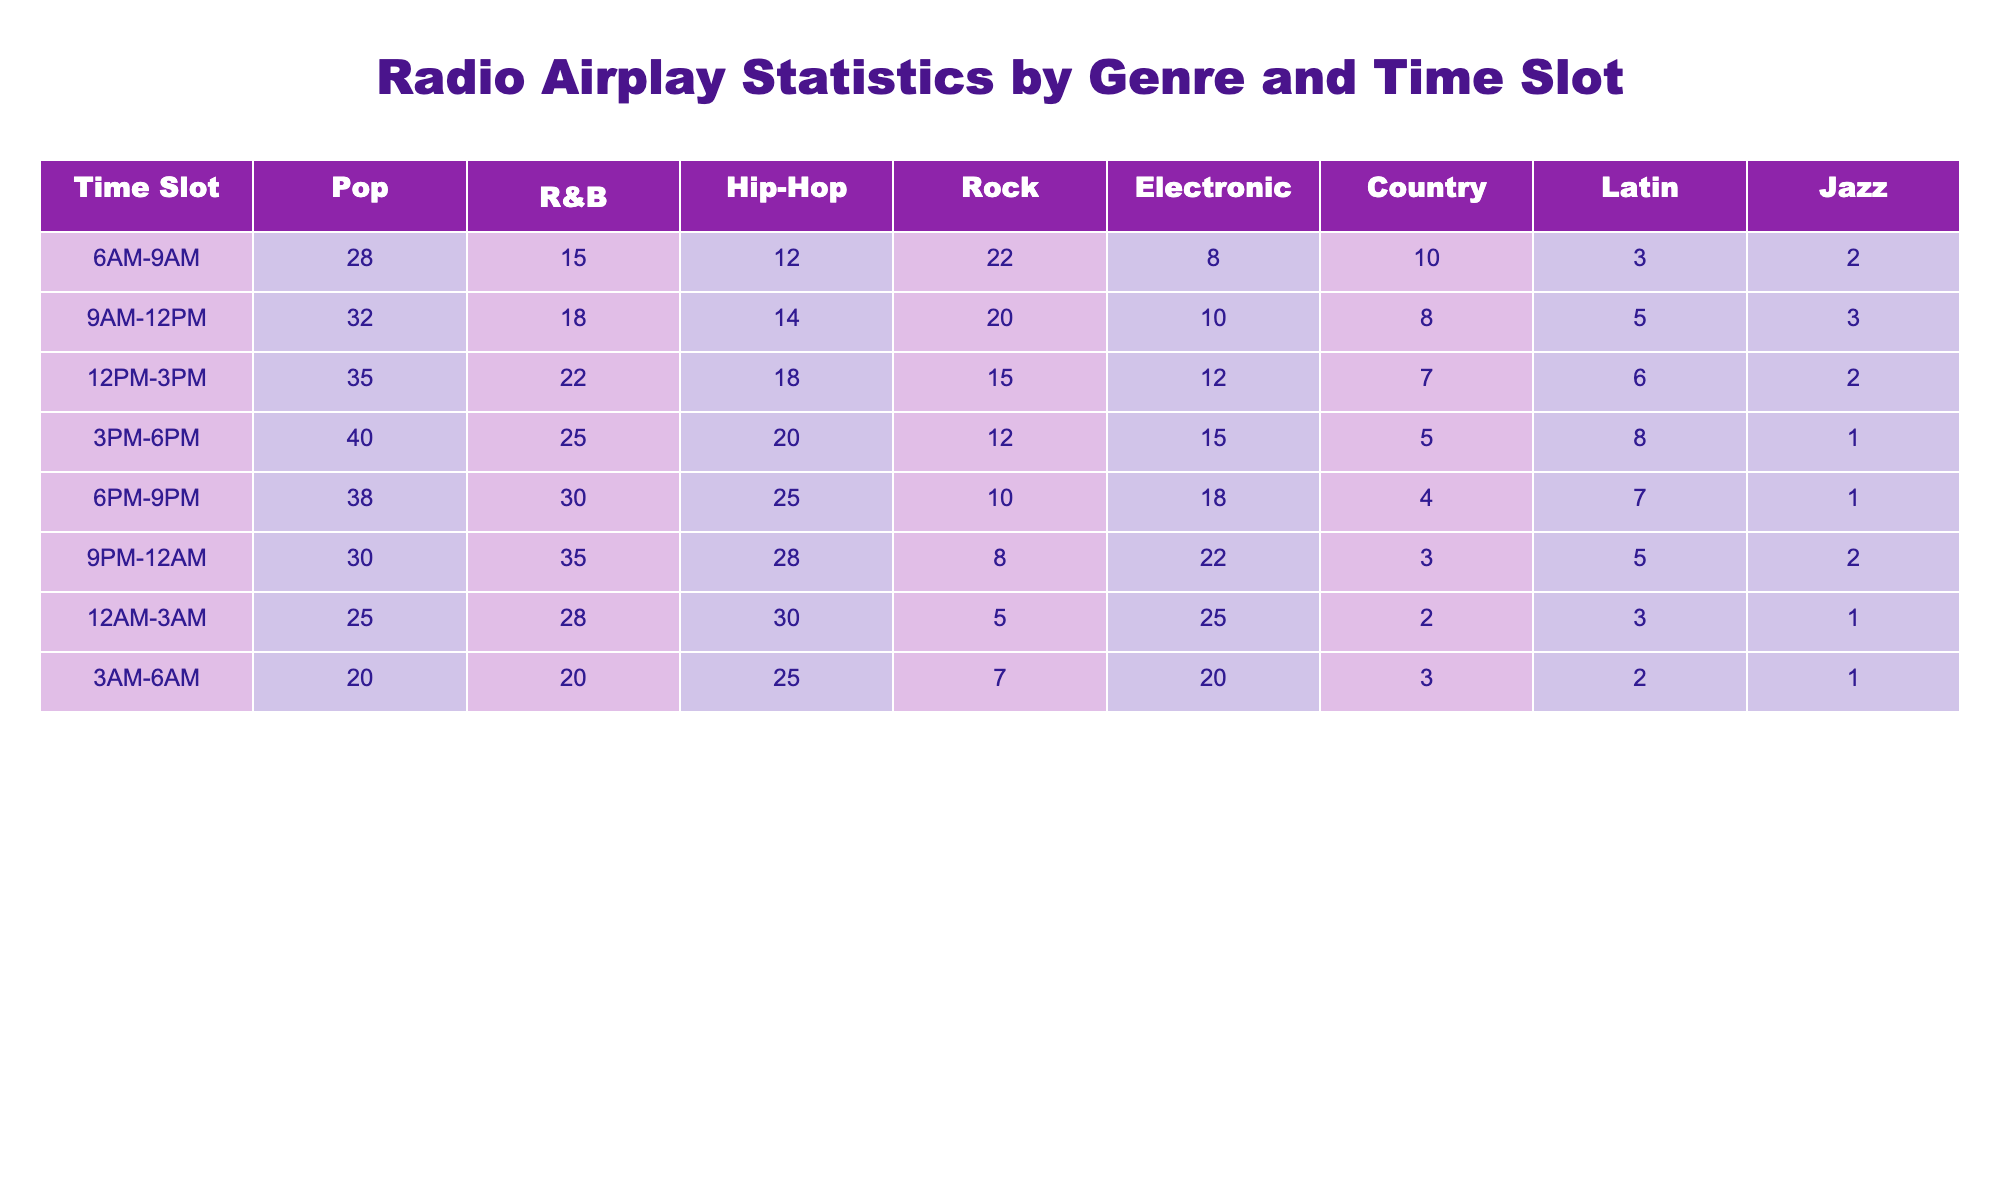What is the highest airplay in the Pop genre? In the table, the highest value for the Pop genre is found in the time slot 12 PM-3 PM, where it shows a value of 35.
Answer: 35 During which time slot did Hip-Hop receive the least airplay? By examining the table, the time slot with the lowest value for Hip-Hop is 6 PM-9 PM, where it shows 10.
Answer: 10 What is the average airplay for R&B during the 6 PM-9 PM and 9 PM-12 AM time slots? The R&B airplay for 6 PM-9 PM is 30 and for 9 PM-12 AM is 35. The sum is 30 + 35 = 65; therefore, the average is 65/2 = 32.5.
Answer: 32.5 Is it true that Country airplay is higher from 3 PM-6 PM than from 12 PM-3 PM? In the table, Country airplay from 3 PM-6 PM is 5, and from 12 PM-3 PM it is 7. Since 5 is less than 7, the statement is false.
Answer: False Which genre has the most consistent airplay throughout all time slots? We need to check the values for each genre; after reviewing, R&B shows the most gradual changes without significant spikes or drops across time slots when compared to the other genres.
Answer: R&B What is the average airplay for Jazz across all time slots? To find the average airplay for Jazz: (2 + 3 + 2 + 1 + 1 + 3 + 1 + 1) = 14. There are 8 time slots, so the average is 14/8 = 1.75.
Answer: 1.75 What genre had the greatest increase in airplay from 3 PM-6 PM to 6 PM-9 PM? The values are 12 for Rock at 3 PM-6 PM and 10 for 6 PM-9 PM, indicating a drop in airplay. Electronic went from 15 to 18, which is an increase of 3. Thus, Electronic had the greatest increase.
Answer: Electronic In how many time slots did Latin music achieve airplay greater than or equal to 5? By scanning through the values, Latin had an airplay value of 5 in the 9 AM-12 PM time slot and higher in the 3 PM-6 PM time slot (8). Thus, it achieved this in 2 time slots.
Answer: 2 Which time slot experienced the maximum airplay for Electronic music? Looking at the table, the highest airplay for Electronic music occurs in the 12AM-3AM time slot, which is 25.
Answer: 25 Were there any time slots where Rock received equal to or less than 10 airplay? Investigating the table, we find Rock's airplay in the 6 PM-9 PM and the 9 PM-12 AM time slots are both ≤ 10. Therefore, the answer is yes.
Answer: Yes 